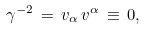<formula> <loc_0><loc_0><loc_500><loc_500>\gamma ^ { - 2 } \, = \, v _ { \alpha } \, v ^ { \alpha } \, \equiv \, 0 ,</formula> 